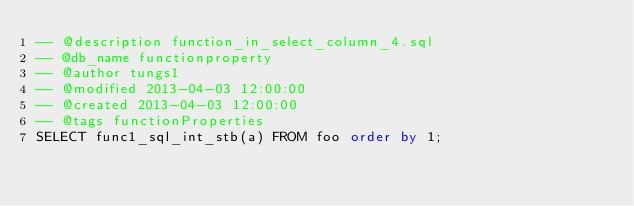<code> <loc_0><loc_0><loc_500><loc_500><_SQL_>-- @description function_in_select_column_4.sql
-- @db_name functionproperty
-- @author tungs1
-- @modified 2013-04-03 12:00:00
-- @created 2013-04-03 12:00:00
-- @tags functionProperties 
SELECT func1_sql_int_stb(a) FROM foo order by 1; 
</code> 